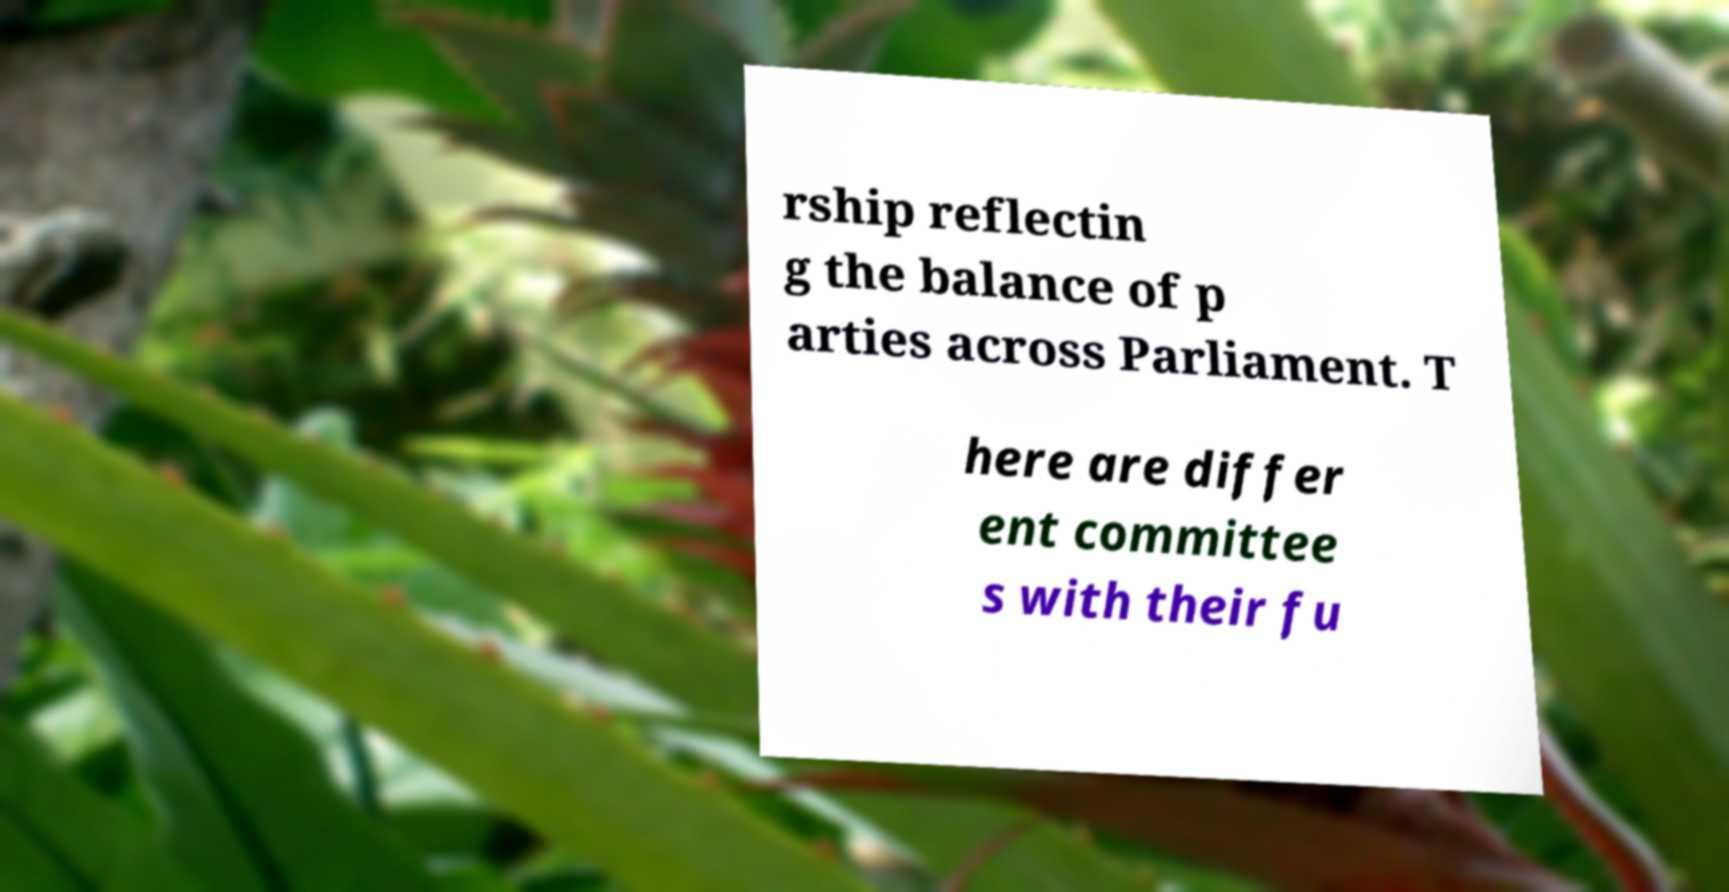Can you read and provide the text displayed in the image?This photo seems to have some interesting text. Can you extract and type it out for me? rship reflectin g the balance of p arties across Parliament. T here are differ ent committee s with their fu 